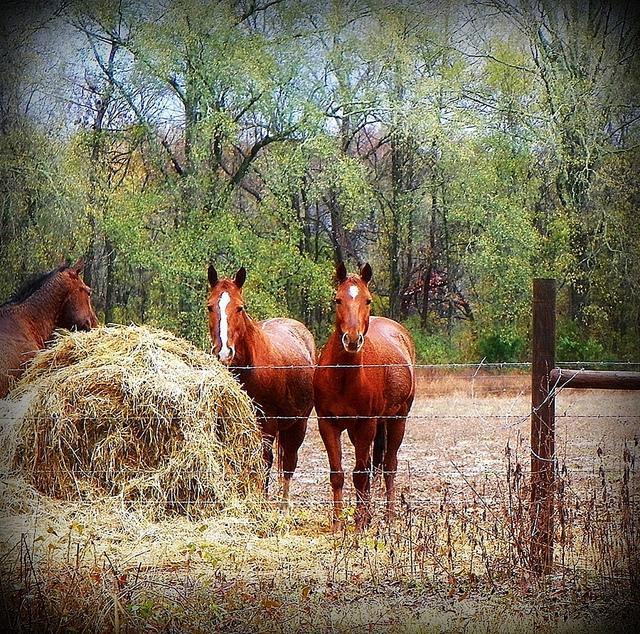How many horses are facing the photographer?
Give a very brief answer. 2. How many horses are there?
Give a very brief answer. 3. How many people are kayaking?
Give a very brief answer. 0. 